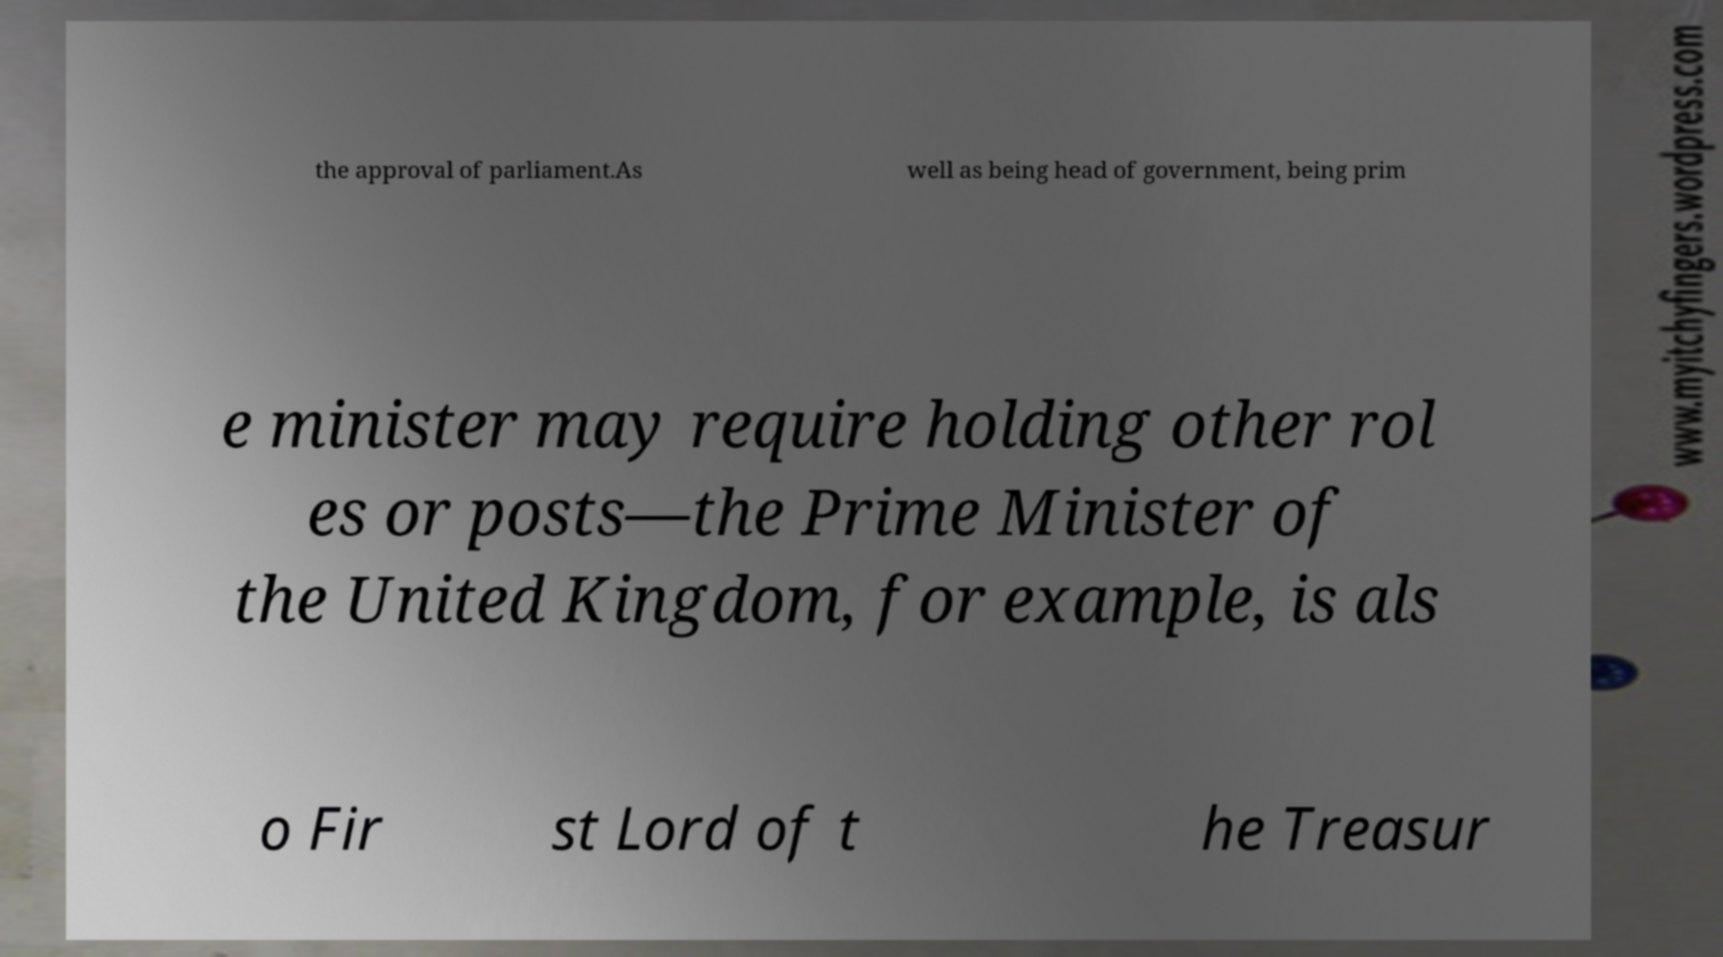Please identify and transcribe the text found in this image. the approval of parliament.As well as being head of government, being prim e minister may require holding other rol es or posts—the Prime Minister of the United Kingdom, for example, is als o Fir st Lord of t he Treasur 